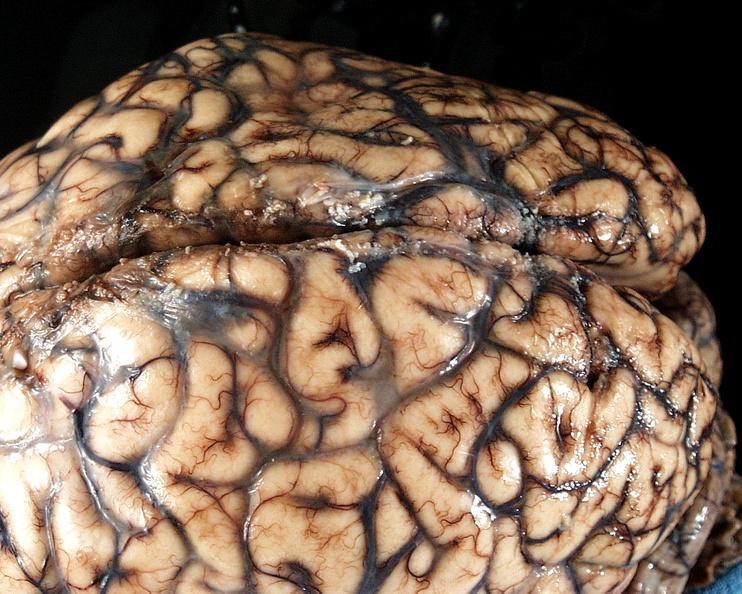s pneumocystis present?
Answer the question using a single word or phrase. No 